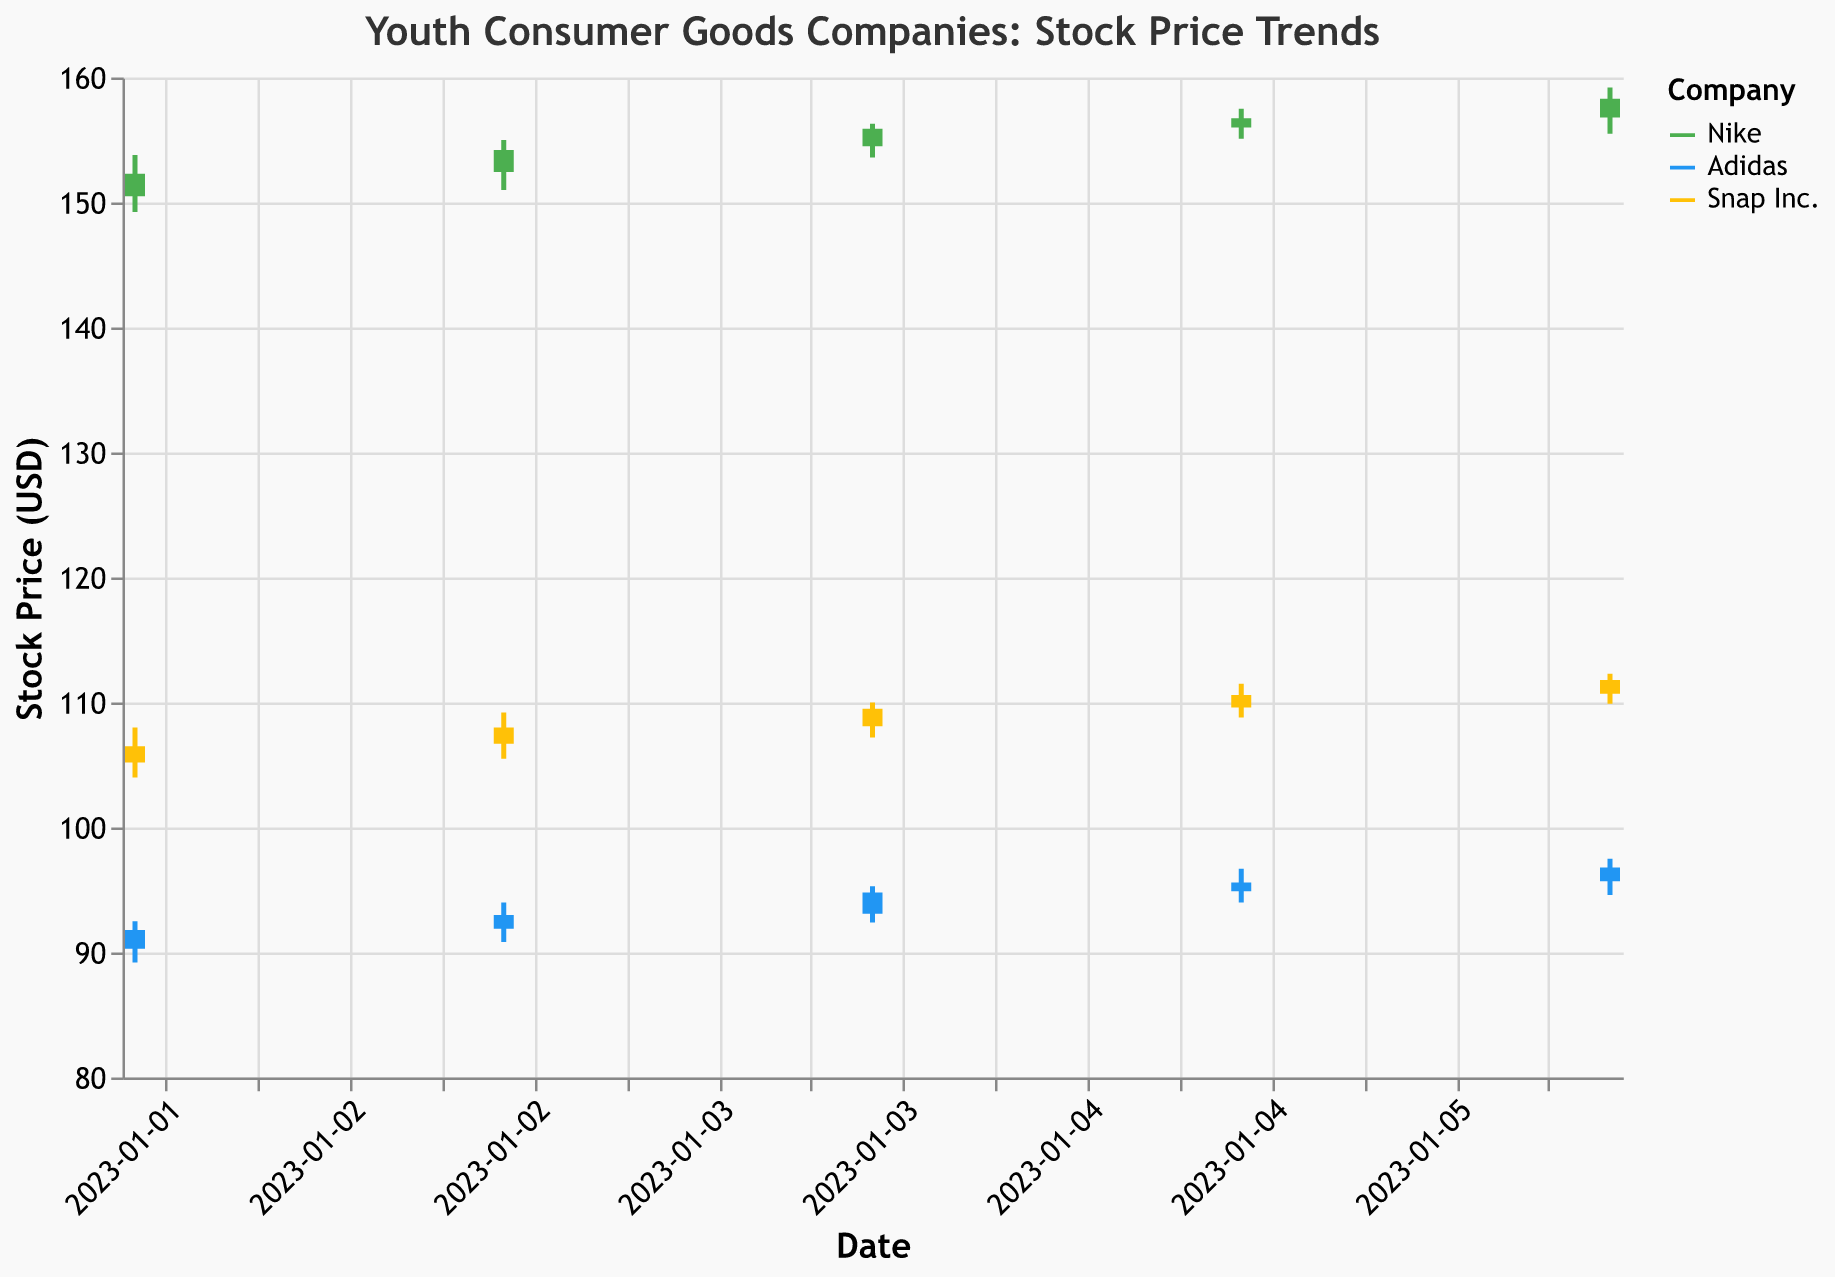What is the title of the plot? The title of the plot is stated at the top of the chart.
Answer: Youth Consumer Goods Companies: Stock Price Trends What are the three companies represented in the plot? The three companies can be identified by the legend or the labels next to the corresponding lines/bars in the plot.
Answer: Nike, Adidas, Snap Inc Which company had the highest closing price on January 3, 2023? Look at the "Close" values for January 3, 2023, for all three companies and identify the highest one. Nike's closing price is 154.20, Adidas is 93.00, and Snap Inc. is 108.00.
Answer: Nike What was the closing stock price of Adidas on January 5, 2023? To find this, look at the "Close" value for Adidas on January 5, 2023, in the plot.
Answer: 95.60 How did the stock price trend for Nike from January 2 to January 6, 2023? Observing Nike's stock prices from January 2 to January 6, 2023 shows that its closing price increased from 152.30 to 158.30.
Answer: Upward trend Between January 2 and January 6, 2023, which company's stock had the highest increase in the closing price? Calculate the difference in closing prices from January 2 to January 6, 2023, for all three companies. Nike increased from 152.30 to 158.30 (6.00), Adidas from 91.80 to 96.80 (5.00), and Snap Inc. from 106.50 to 111.80 (5.30). Nike had the highest increase.
Answer: Nike Which company had the most consistent closing prices over the five days? Examine the closing prices for each company and calculate the range (highest close - lowest close). Nike: 158.30 - 152.30 = 6.00, Adidas: 96.80 - 91.80 = 5.00, Snap Inc.: 111.80 - 106.50 = 5.30. Adidas is the most consistent.
Answer: Adidas What was the volume of Snap Inc. stocks traded on January 3, 2023? Check the "Volume" value for Snap Inc. on January 3, 2023, in the plot.
Answer: 1203400 By how much did Snap Inc.'s stock price increase from its opening to closing price on January 4, 2023? Find the difference between the "Open" and "Close" prices for Snap Inc. on January 4, 2023. The opening price is 108.10, and the closing price is 109.50. The increase is 109.50 - 108.10.
Answer: 1.40 Which company had the highest trading volume on January 6, 2023? Compare the "Volume" values for January 6, 2023, across the three companies. Nike had 1287000, Adidas had 1043200, and Snap Inc. had 1224500. Nike had the highest volume.
Answer: Nike 